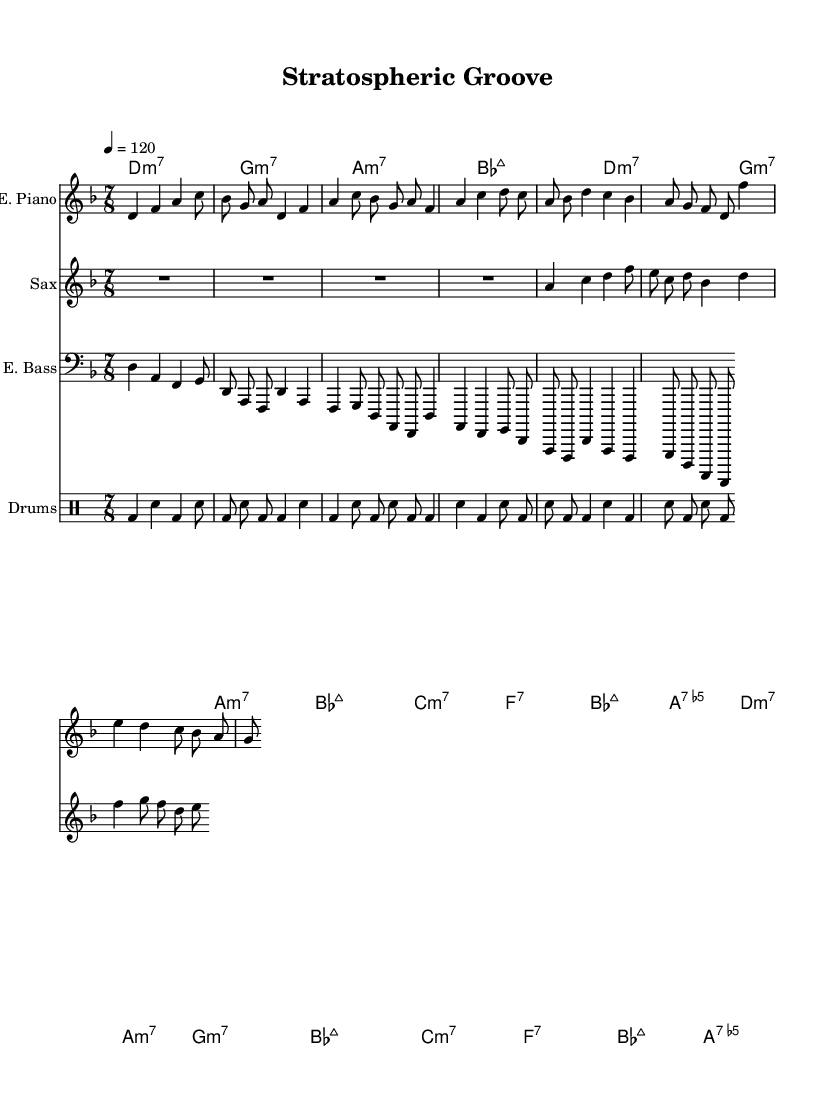What is the key signature of this music? The key signature is D minor, indicated by the presence of one flat (B flat) which is a characteristic of D minor.
Answer: D minor What is the time signature of this piece? The time signature is 7/8, shown at the beginning of the score, indicating that there are seven beats in each measure and that the eighth note is the basic unit of time.
Answer: 7/8 What is the tempo marking? The tempo marking is 120 beats per minute, indicated as "4 = 120." This means that the quarter note gets one beat, and the tempo should be played at this speed.
Answer: 120 How many measures are in the introduction? The introduction consists of one measure, which can be identified as a distinct section at the beginning of the electric piano part.
Answer: 1 What instruments are featured in this piece? The instruments featured are electric piano, saxophone, electric bass, and drums, as each is labeled in its respective staff at the beginning of the score.
Answer: Electric piano, saxophone, electric bass, drums Which chord is played in the first measure of the introduction? The first chord in the introduction is D minor 7, as indicated by the chord notation at the beginning of the score.
Answer: D minor 7 How many beats does the saxophone rest in the first measure? The saxophone rests for the entire measure of 7/8, as indicated by the "R" notation which signifies a rest.
Answer: 7 